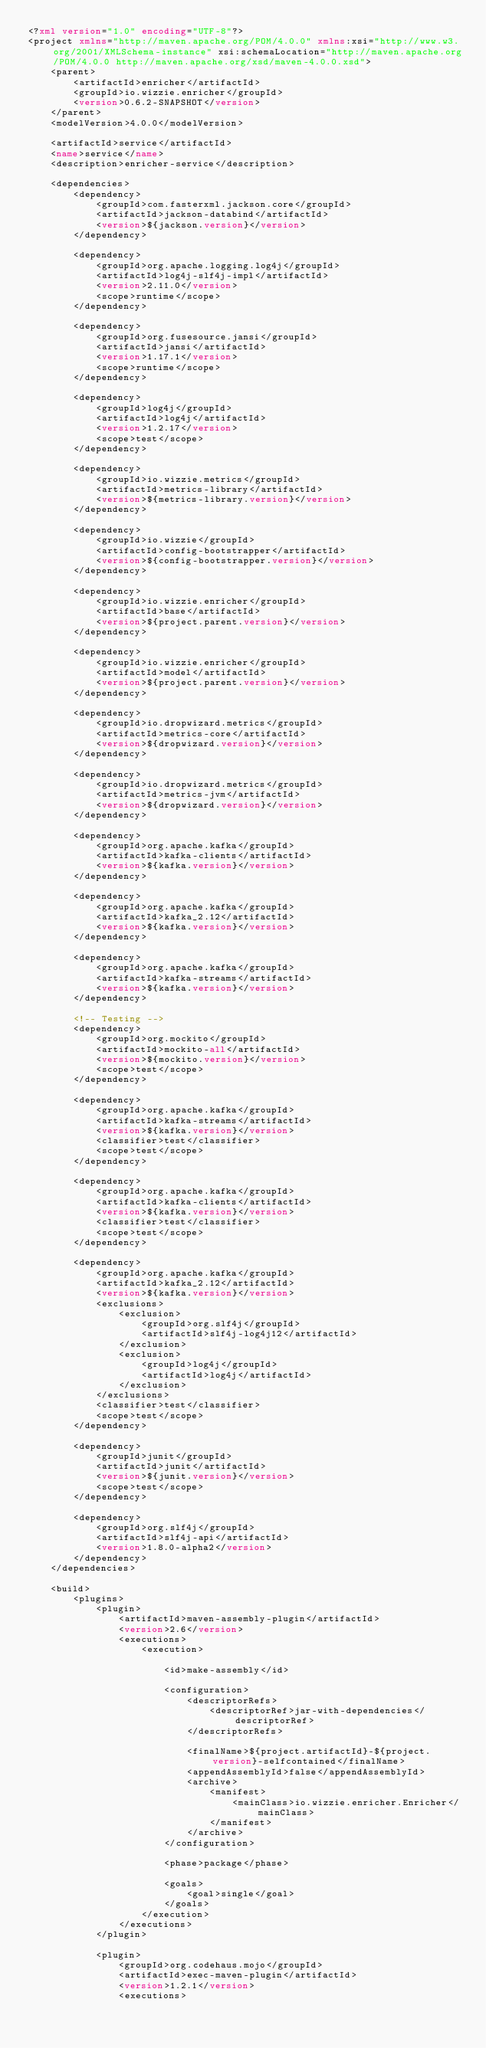Convert code to text. <code><loc_0><loc_0><loc_500><loc_500><_XML_><?xml version="1.0" encoding="UTF-8"?>
<project xmlns="http://maven.apache.org/POM/4.0.0" xmlns:xsi="http://www.w3.org/2001/XMLSchema-instance" xsi:schemaLocation="http://maven.apache.org/POM/4.0.0 http://maven.apache.org/xsd/maven-4.0.0.xsd">
    <parent>
        <artifactId>enricher</artifactId>
        <groupId>io.wizzie.enricher</groupId>
        <version>0.6.2-SNAPSHOT</version>
    </parent>
    <modelVersion>4.0.0</modelVersion>

    <artifactId>service</artifactId>
    <name>service</name>
    <description>enricher-service</description>

    <dependencies>
        <dependency>
            <groupId>com.fasterxml.jackson.core</groupId>
            <artifactId>jackson-databind</artifactId>
            <version>${jackson.version}</version>
        </dependency>

        <dependency>
            <groupId>org.apache.logging.log4j</groupId>
            <artifactId>log4j-slf4j-impl</artifactId>
            <version>2.11.0</version>
            <scope>runtime</scope>
        </dependency>

        <dependency>
            <groupId>org.fusesource.jansi</groupId>
            <artifactId>jansi</artifactId>
            <version>1.17.1</version>
            <scope>runtime</scope>
        </dependency>

        <dependency>
            <groupId>log4j</groupId>
            <artifactId>log4j</artifactId>
            <version>1.2.17</version>
            <scope>test</scope>
        </dependency>

        <dependency>
            <groupId>io.wizzie.metrics</groupId>
            <artifactId>metrics-library</artifactId>
            <version>${metrics-library.version}</version>
        </dependency>

        <dependency>
            <groupId>io.wizzie</groupId>
            <artifactId>config-bootstrapper</artifactId>
            <version>${config-bootstrapper.version}</version>
        </dependency>

        <dependency>
            <groupId>io.wizzie.enricher</groupId>
            <artifactId>base</artifactId>
            <version>${project.parent.version}</version>
        </dependency>

        <dependency>
            <groupId>io.wizzie.enricher</groupId>
            <artifactId>model</artifactId>
            <version>${project.parent.version}</version>
        </dependency>

        <dependency>
            <groupId>io.dropwizard.metrics</groupId>
            <artifactId>metrics-core</artifactId>
            <version>${dropwizard.version}</version>
        </dependency>

        <dependency>
            <groupId>io.dropwizard.metrics</groupId>
            <artifactId>metrics-jvm</artifactId>
            <version>${dropwizard.version}</version>
        </dependency>

        <dependency>
            <groupId>org.apache.kafka</groupId>
            <artifactId>kafka-clients</artifactId>
            <version>${kafka.version}</version>
        </dependency>

        <dependency>
            <groupId>org.apache.kafka</groupId>
            <artifactId>kafka_2.12</artifactId>
            <version>${kafka.version}</version>
        </dependency>

        <dependency>
            <groupId>org.apache.kafka</groupId>
            <artifactId>kafka-streams</artifactId>
            <version>${kafka.version}</version>
        </dependency>

        <!-- Testing -->
        <dependency>
            <groupId>org.mockito</groupId>
            <artifactId>mockito-all</artifactId>
            <version>${mockito.version}</version>
            <scope>test</scope>
        </dependency>

        <dependency>
            <groupId>org.apache.kafka</groupId>
            <artifactId>kafka-streams</artifactId>
            <version>${kafka.version}</version>
            <classifier>test</classifier>
            <scope>test</scope>
        </dependency>

        <dependency>
            <groupId>org.apache.kafka</groupId>
            <artifactId>kafka-clients</artifactId>
            <version>${kafka.version}</version>
            <classifier>test</classifier>
            <scope>test</scope>
        </dependency>

        <dependency>
            <groupId>org.apache.kafka</groupId>
            <artifactId>kafka_2.12</artifactId>
            <version>${kafka.version}</version>
            <exclusions>
                <exclusion>
                    <groupId>org.slf4j</groupId>
                    <artifactId>slf4j-log4j12</artifactId>
                </exclusion>
                <exclusion>
                    <groupId>log4j</groupId>
                    <artifactId>log4j</artifactId>
                </exclusion>
            </exclusions>
            <classifier>test</classifier>
            <scope>test</scope>
        </dependency>

        <dependency>
            <groupId>junit</groupId>
            <artifactId>junit</artifactId>
            <version>${junit.version}</version>
            <scope>test</scope>
        </dependency>

        <dependency>
            <groupId>org.slf4j</groupId>
            <artifactId>slf4j-api</artifactId>
            <version>1.8.0-alpha2</version>
        </dependency>
    </dependencies>

    <build>
        <plugins>
            <plugin>
                <artifactId>maven-assembly-plugin</artifactId>
                <version>2.6</version>
                <executions>
                    <execution>

                        <id>make-assembly</id>

                        <configuration>
                            <descriptorRefs>
                                <descriptorRef>jar-with-dependencies</descriptorRef>
                            </descriptorRefs>

                            <finalName>${project.artifactId}-${project.version}-selfcontained</finalName>
                            <appendAssemblyId>false</appendAssemblyId>
                            <archive>
                                <manifest>
                                    <mainClass>io.wizzie.enricher.Enricher</mainClass>
                                </manifest>
                            </archive>
                        </configuration>

                        <phase>package</phase>

                        <goals>
                            <goal>single</goal>
                        </goals>
                    </execution>
                </executions>
            </plugin>

            <plugin>
                <groupId>org.codehaus.mojo</groupId>
                <artifactId>exec-maven-plugin</artifactId>
                <version>1.2.1</version>
                <executions></code> 